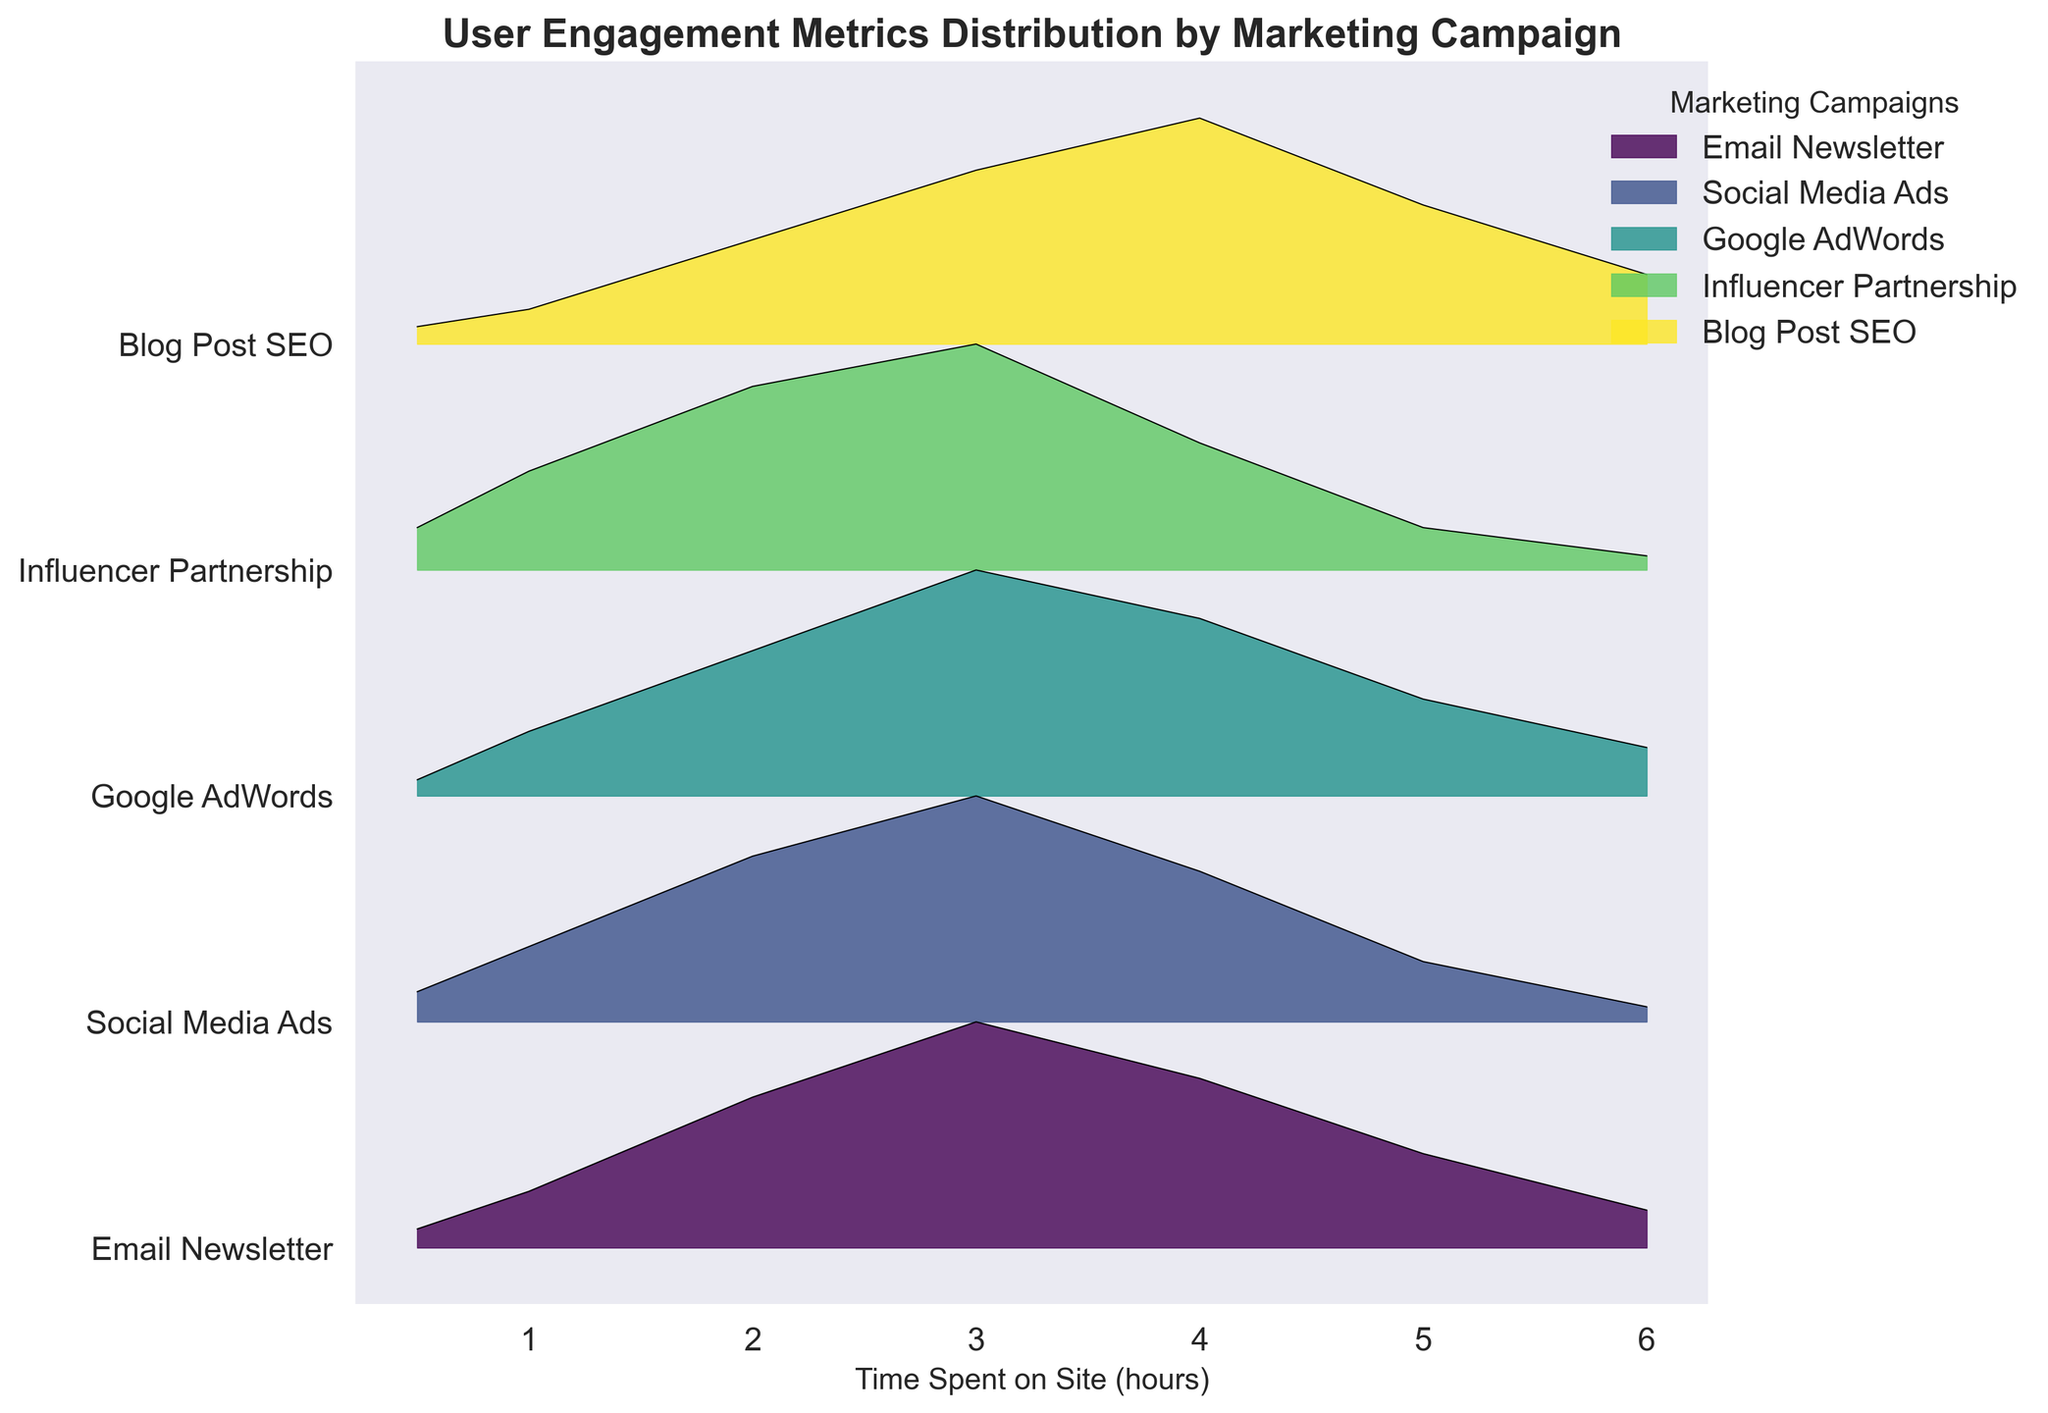How many marketing campaigns are compared in the figure? The y-axis labels show each marketing campaign analyzed in the figure.
Answer: 5 What is the title of the figure? The title is displayed prominently at the top of the figure.
Answer: User Engagement Metrics Distribution by Marketing Campaign Which marketing campaign shows the highest density of users who spent 3 hours on the site? Find the peak height of the curve at the 3-hour mark for each campaign.
Answer: Influencer Partnership Which campaign has the most spread-out distribution of time spent on the site? Look for the campaign with a wide range of user engagement extending across the x-axis.
Answer: Blog Post SEO At which time spent does the Email Newsletter campaign show the highest density? Observe the peak of the Email Newsletter curve on the x-axis.
Answer: 3 hours Between Social Media Ads and Google AdWords, which campaign has a higher user engagement at 4 hours? Compare the height of the curves at the 4-hour mark for Social Media Ads and Google AdWords.
Answer: Google AdWords Are there any marketing campaigns with similar distribution shapes? Which ones? Compare the curves to see which marketing campaigns have similarly shaped peaks and spreads.
Answer: Email Newsletter and Google AdWords What is the primary color range used in the figure? Look at the color scheme used across the different curves.
Answer: Various shades of green/yellow to blue (viridis colormap) Which marketing campaign has the least user engagement at 6 hours? Check the height of the density curves at the 6-hour mark.
Answer: Influencer Partnership Which marketing campaigns show a peak density at exactly 3 hours? Identify the campaigns where the curve reaches its maximum height at the 3-hour mark.
Answer: Influencer Partnership, Google AdWords 